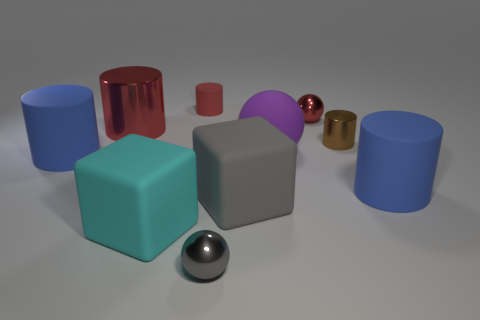Subtract all brown cylinders. How many cylinders are left? 4 Subtract all red metallic cylinders. How many cylinders are left? 4 Subtract all cyan cylinders. Subtract all gray cubes. How many cylinders are left? 5 Subtract all blocks. How many objects are left? 8 Subtract all matte objects. Subtract all large blue rubber things. How many objects are left? 2 Add 6 purple balls. How many purple balls are left? 7 Add 6 large gray things. How many large gray things exist? 7 Subtract 0 red cubes. How many objects are left? 10 